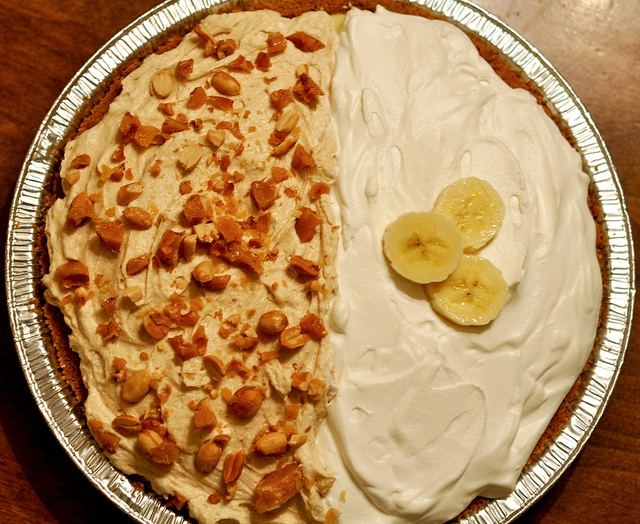Describe the objects in this image and their specific colors. I can see cake in maroon, tan, and red tones and banana in maroon, tan, orange, and olive tones in this image. 